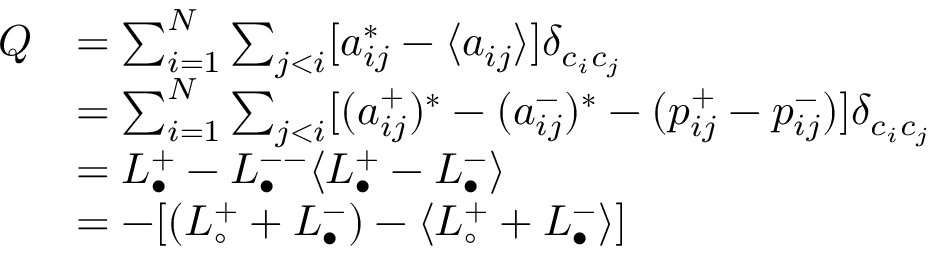Convert formula to latex. <formula><loc_0><loc_0><loc_500><loc_500>\begin{array} { r l } { Q } & { = \sum _ { i = 1 } ^ { N } \sum _ { j < i } [ a _ { i j } ^ { * } - \langle a _ { i j } \rangle ] \delta _ { c _ { i } c _ { j } } } \\ & { = \sum _ { i = 1 } ^ { N } \sum _ { j < i } [ ( a _ { i j } ^ { + } ) ^ { * } - ( a _ { i j } ^ { - } ) ^ { * } - ( p _ { i j } ^ { + } - p _ { i j } ^ { - } ) ] \delta _ { c _ { i } c _ { j } } } \\ & { = L _ { \bullet } ^ { + } - L _ { \bullet } ^ { - - } \langle L _ { \bullet } ^ { + } - L _ { \bullet } ^ { - } \rangle } \\ & { = - [ ( L _ { \circ } ^ { + } + L _ { \bullet } ^ { - } ) - \langle L _ { \circ } ^ { + } + L _ { \bullet } ^ { - } \rangle ] } \end{array}</formula> 